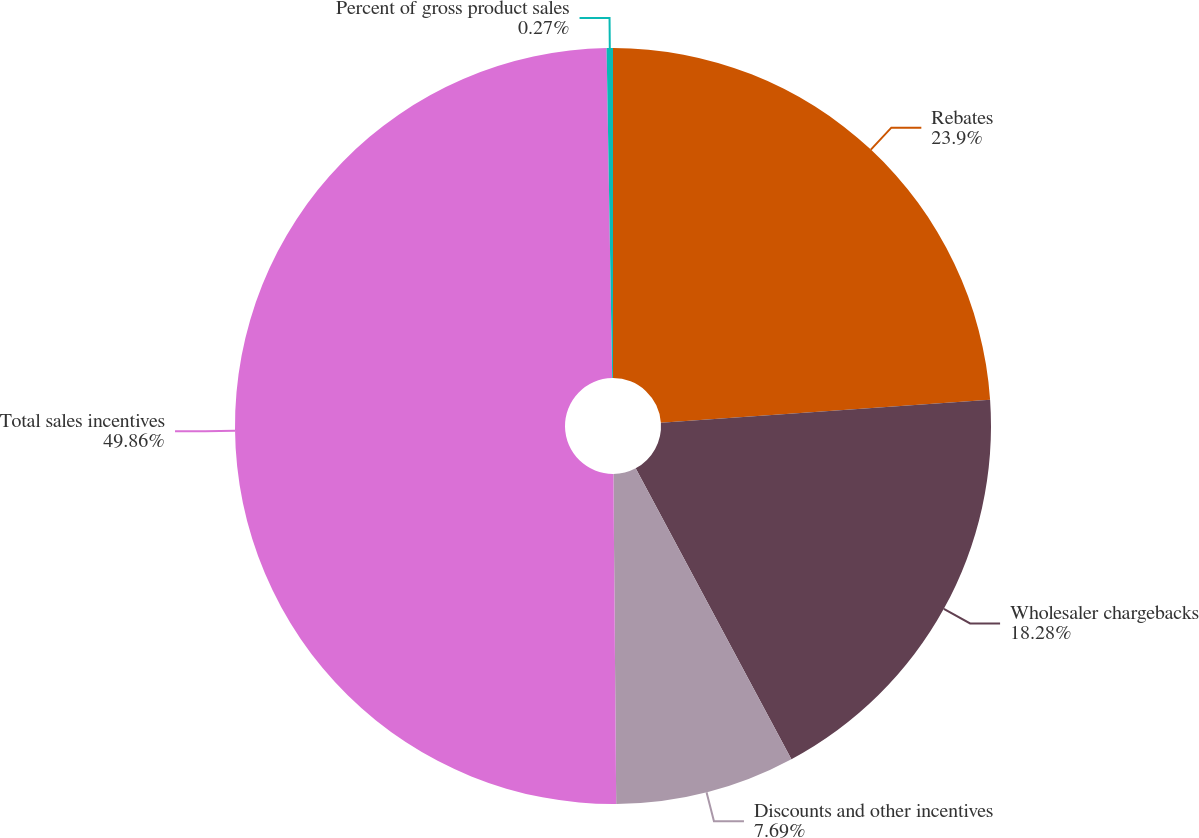Convert chart to OTSL. <chart><loc_0><loc_0><loc_500><loc_500><pie_chart><fcel>Rebates<fcel>Wholesaler chargebacks<fcel>Discounts and other incentives<fcel>Total sales incentives<fcel>Percent of gross product sales<nl><fcel>23.9%<fcel>18.28%<fcel>7.69%<fcel>49.87%<fcel>0.27%<nl></chart> 